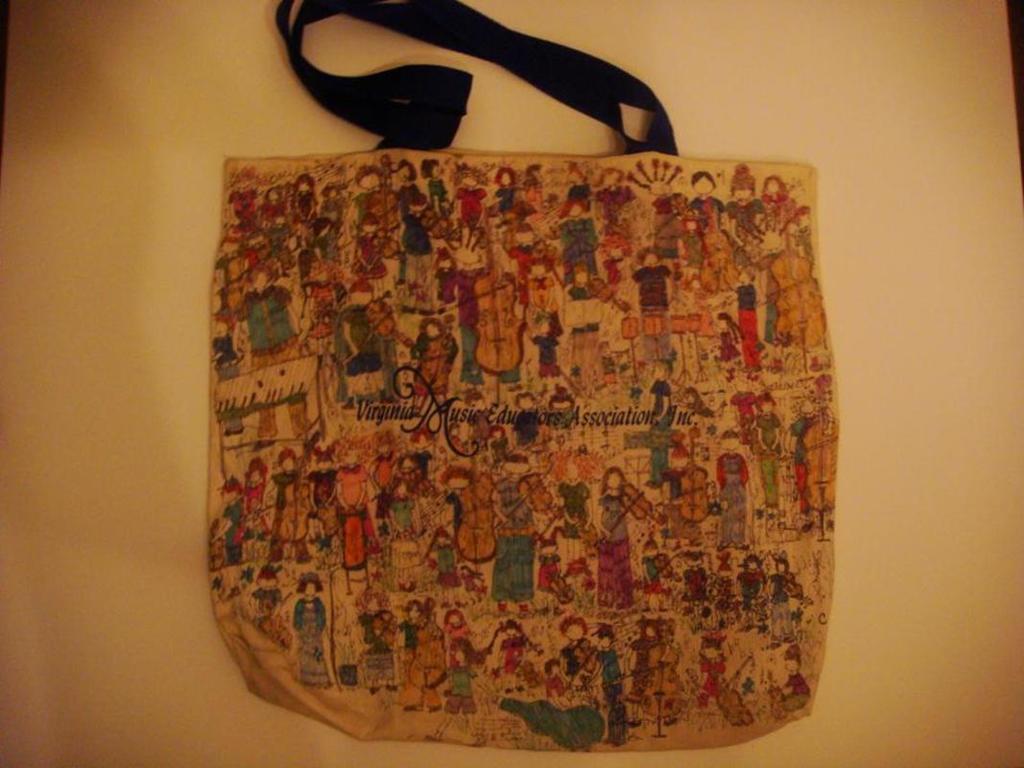In one or two sentences, can you explain what this image depicts? In the picture we can see a bag which is of art and paintings on it, in the background we can see a cream white color. 